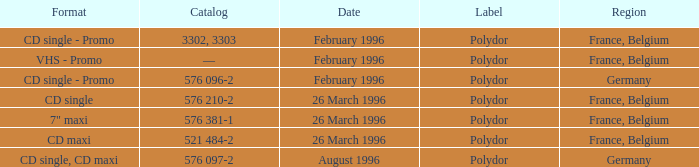Name the region with catalog of 576 097-2 Germany. 